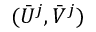<formula> <loc_0><loc_0><loc_500><loc_500>( \bar { U } ^ { j } , \bar { V } ^ { j } )</formula> 